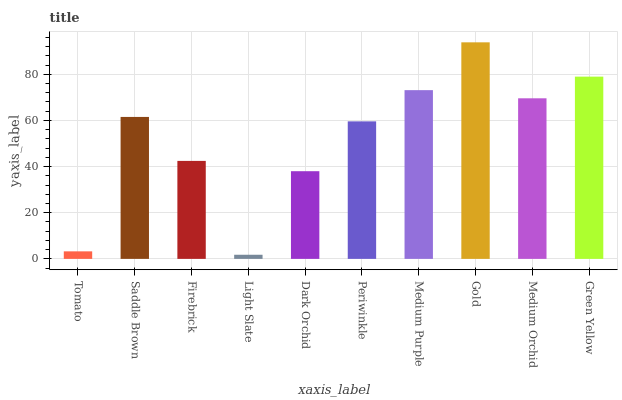Is Light Slate the minimum?
Answer yes or no. Yes. Is Gold the maximum?
Answer yes or no. Yes. Is Saddle Brown the minimum?
Answer yes or no. No. Is Saddle Brown the maximum?
Answer yes or no. No. Is Saddle Brown greater than Tomato?
Answer yes or no. Yes. Is Tomato less than Saddle Brown?
Answer yes or no. Yes. Is Tomato greater than Saddle Brown?
Answer yes or no. No. Is Saddle Brown less than Tomato?
Answer yes or no. No. Is Saddle Brown the high median?
Answer yes or no. Yes. Is Periwinkle the low median?
Answer yes or no. Yes. Is Dark Orchid the high median?
Answer yes or no. No. Is Saddle Brown the low median?
Answer yes or no. No. 